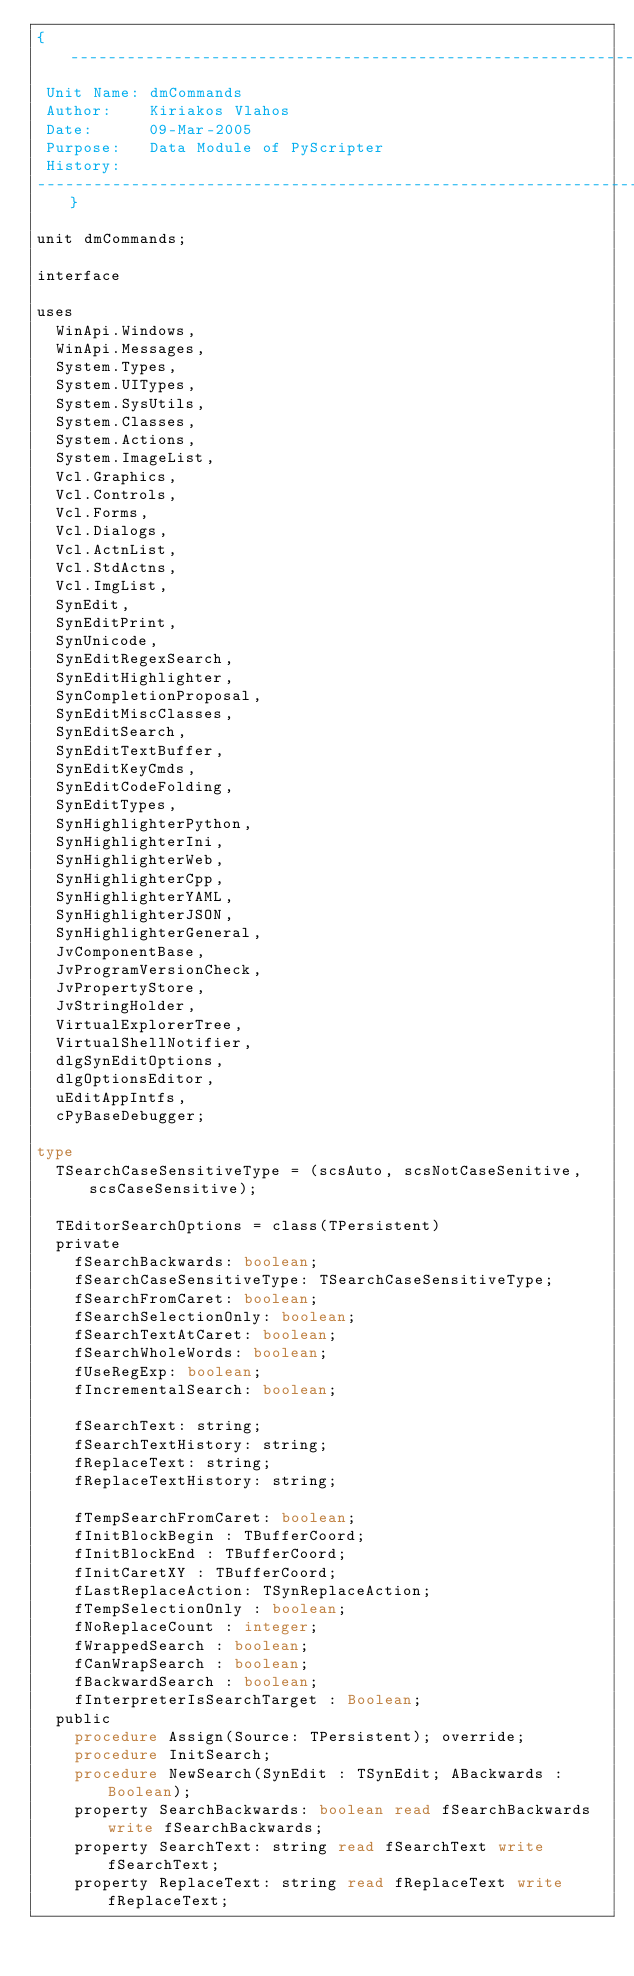<code> <loc_0><loc_0><loc_500><loc_500><_Pascal_>{-----------------------------------------------------------------------------
 Unit Name: dmCommands
 Author:    Kiriakos Vlahos
 Date:      09-Mar-2005
 Purpose:   Data Module of PyScripter
 History:
-----------------------------------------------------------------------------}

unit dmCommands;

interface

uses
  WinApi.Windows,
  WinApi.Messages,
  System.Types,
  System.UITypes,
  System.SysUtils,
  System.Classes,
  System.Actions,
  System.ImageList,
  Vcl.Graphics,
  Vcl.Controls,
  Vcl.Forms,
  Vcl.Dialogs,
  Vcl.ActnList,
  Vcl.StdActns,
  Vcl.ImgList,
  SynEdit,
  SynEditPrint,
  SynUnicode,
  SynEditRegexSearch,
  SynEditHighlighter,
  SynCompletionProposal,
  SynEditMiscClasses,
  SynEditSearch,
  SynEditTextBuffer,
  SynEditKeyCmds,
  SynEditCodeFolding,
  SynEditTypes,
  SynHighlighterPython,
  SynHighlighterIni,
  SynHighlighterWeb,
  SynHighlighterCpp,
  SynHighlighterYAML,
  SynHighlighterJSON,
  SynHighlighterGeneral,
  JvComponentBase,
  JvProgramVersionCheck,
  JvPropertyStore,
  JvStringHolder,
  VirtualExplorerTree,
  VirtualShellNotifier,
  dlgSynEditOptions,
  dlgOptionsEditor,
  uEditAppIntfs,
  cPyBaseDebugger;

type
  TSearchCaseSensitiveType = (scsAuto, scsNotCaseSenitive, scsCaseSensitive);

  TEditorSearchOptions = class(TPersistent)
  private
    fSearchBackwards: boolean;
    fSearchCaseSensitiveType: TSearchCaseSensitiveType;
    fSearchFromCaret: boolean;
    fSearchSelectionOnly: boolean;
    fSearchTextAtCaret: boolean;
    fSearchWholeWords: boolean;
    fUseRegExp: boolean;
    fIncrementalSearch: boolean;

    fSearchText: string;
    fSearchTextHistory: string;
    fReplaceText: string;
    fReplaceTextHistory: string;

    fTempSearchFromCaret: boolean;
    fInitBlockBegin : TBufferCoord;
    fInitBlockEnd : TBufferCoord;
    fInitCaretXY : TBufferCoord;
    fLastReplaceAction: TSynReplaceAction;
    fTempSelectionOnly : boolean;
    fNoReplaceCount : integer;
    fWrappedSearch : boolean;
    fCanWrapSearch : boolean;
    fBackwardSearch : boolean;
    fInterpreterIsSearchTarget : Boolean;
  public
    procedure Assign(Source: TPersistent); override;
    procedure InitSearch;
    procedure NewSearch(SynEdit : TSynEdit; ABackwards : Boolean);
    property SearchBackwards: boolean read fSearchBackwards write fSearchBackwards;
    property SearchText: string read fSearchText write fSearchText;
    property ReplaceText: string read fReplaceText write fReplaceText;</code> 